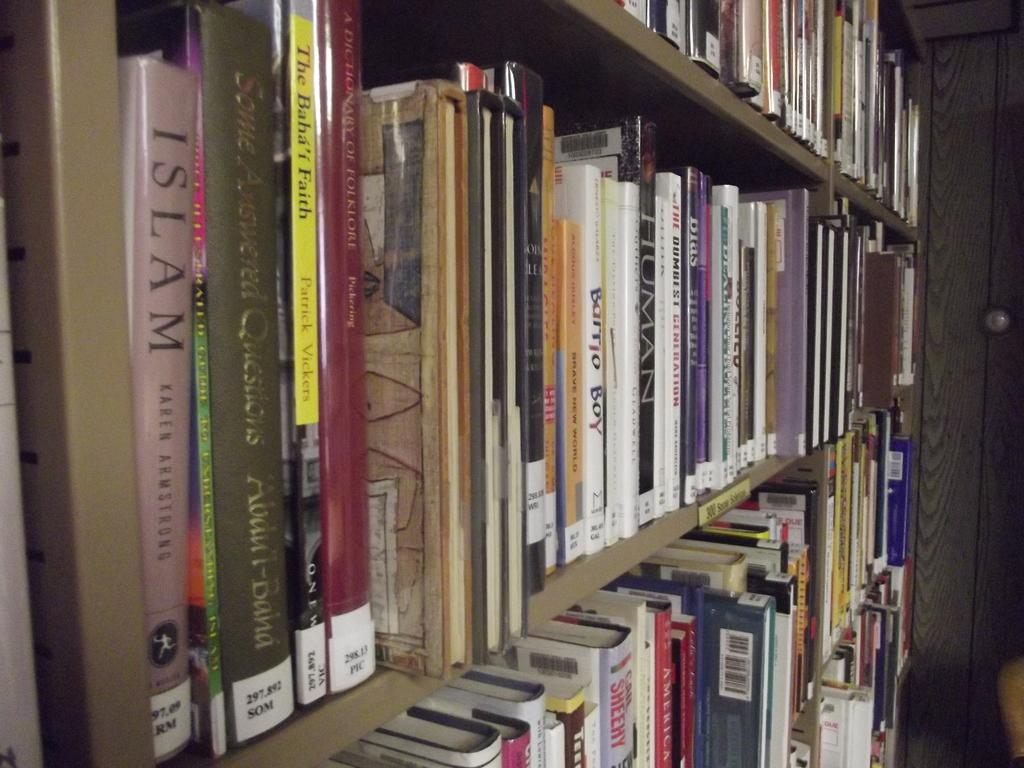What is the primary subject of the image? The primary subject of the image is many books. How are the books arranged in the image? The books are placed in a wooden shelf. What type of test is being conducted with the books in the image? There is no test being conducted in the image; it simply shows books placed in a wooden shelf. 